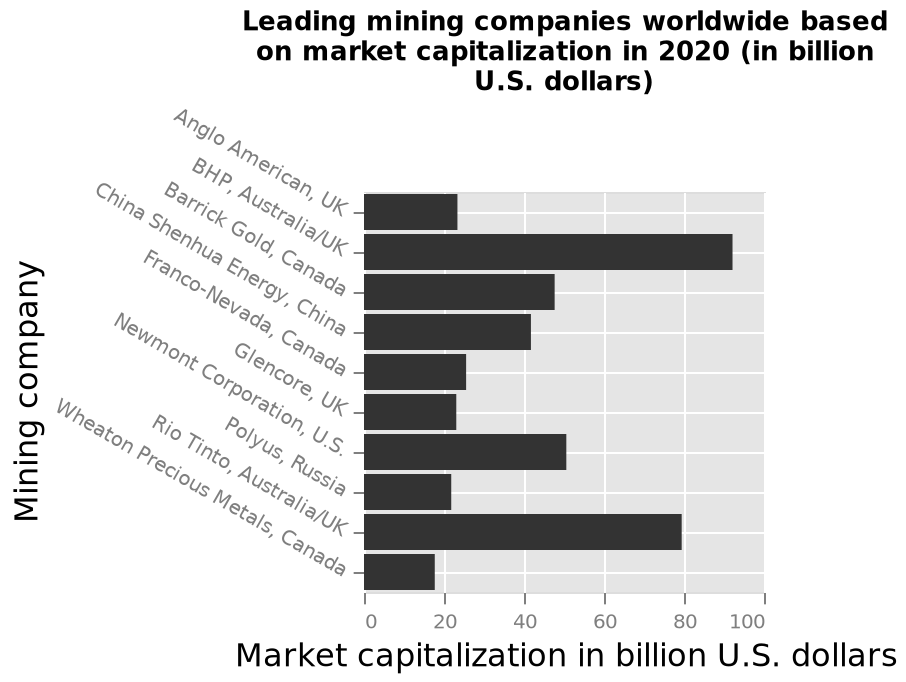<image>
Which mining company is listed first on the y-axis? The mining company listed first on the y-axis is Anglo American, UK. What company has the highest market capitalisation?  BHP Offer a thorough analysis of the image. Mining company BHP has the highest market capitalisation. It is closely followed by Rio Tinto. Wheaton Precious Metals has the lowest market capitalisation. 